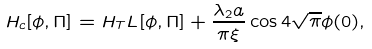Convert formula to latex. <formula><loc_0><loc_0><loc_500><loc_500>H _ { c } [ \phi , \Pi ] = H _ { T } L [ \phi , \Pi ] + \frac { \lambda _ { 2 } a } { \pi \xi } \cos 4 \sqrt { \pi } \phi ( 0 ) ,</formula> 